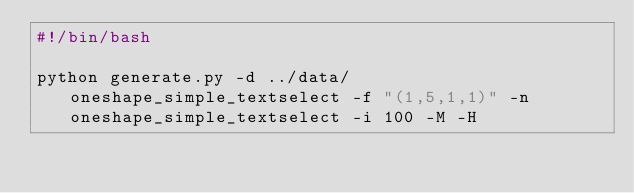<code> <loc_0><loc_0><loc_500><loc_500><_Bash_>#!/bin/bash

python generate.py -d ../data/oneshape_simple_textselect -f "(1,5,1,1)" -n oneshape_simple_textselect -i 100 -M -H
</code> 